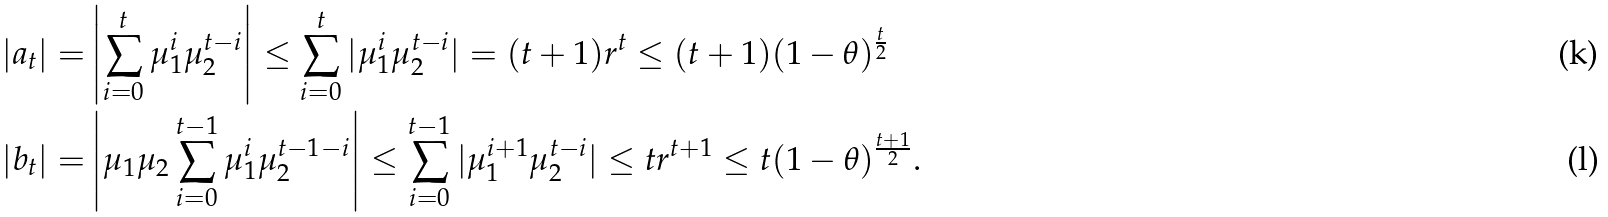<formula> <loc_0><loc_0><loc_500><loc_500>| a _ { t } | = & \left | \sum _ { i = 0 } ^ { t } \mu _ { 1 } ^ { i } \mu _ { 2 } ^ { t - i } \right | \leq \sum _ { i = 0 } ^ { t } | \mu _ { 1 } ^ { i } \mu _ { 2 } ^ { t - i } | = ( t + 1 ) r ^ { t } \leq ( t + 1 ) ( 1 - \theta ) ^ { \frac { t } { 2 } } \\ | b _ { t } | = & \left | \mu _ { 1 } \mu _ { 2 } \sum _ { i = 0 } ^ { t - 1 } \mu _ { 1 } ^ { i } \mu _ { 2 } ^ { t - 1 - i } \right | \leq \sum _ { i = 0 } ^ { t - 1 } | \mu _ { 1 } ^ { i + 1 } \mu _ { 2 } ^ { t - i } | \leq t r ^ { t + 1 } \leq t ( 1 - \theta ) ^ { \frac { t + 1 } { 2 } } .</formula> 